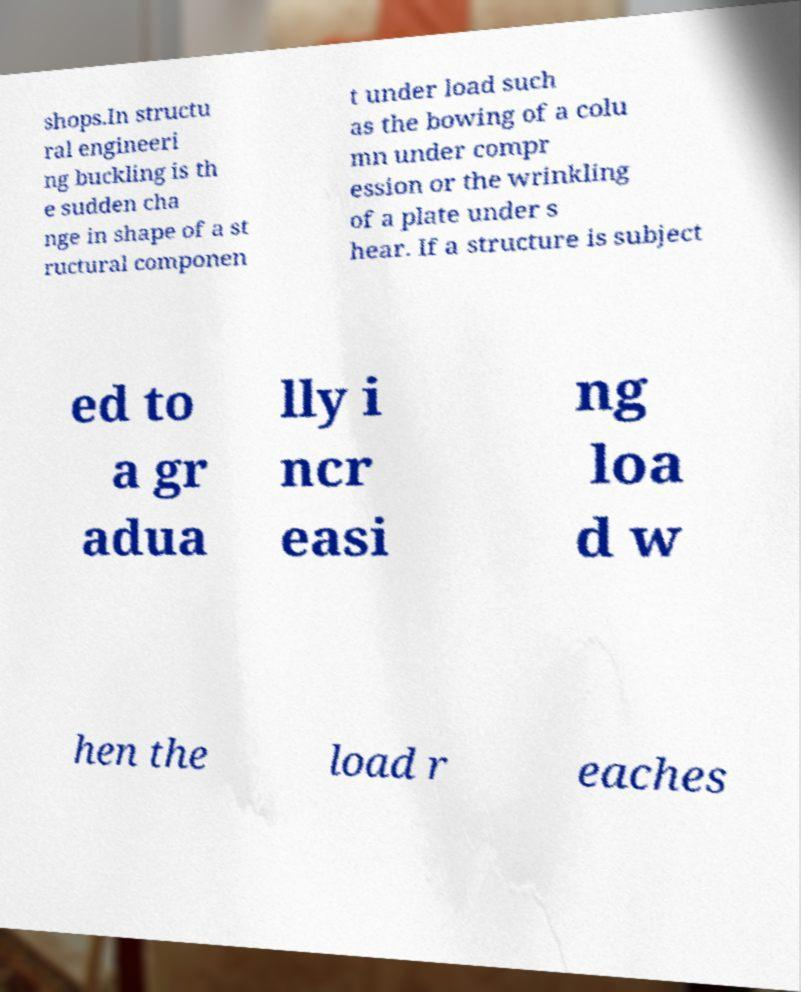Could you extract and type out the text from this image? shops.In structu ral engineeri ng buckling is th e sudden cha nge in shape of a st ructural componen t under load such as the bowing of a colu mn under compr ession or the wrinkling of a plate under s hear. If a structure is subject ed to a gr adua lly i ncr easi ng loa d w hen the load r eaches 